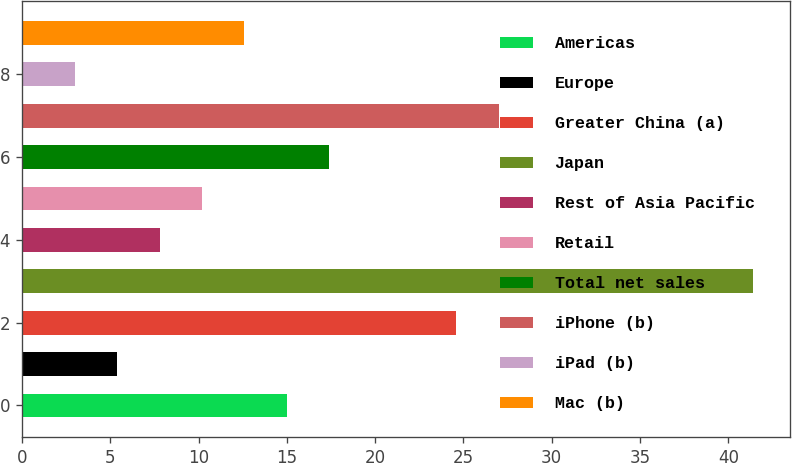Convert chart to OTSL. <chart><loc_0><loc_0><loc_500><loc_500><bar_chart><fcel>Americas<fcel>Europe<fcel>Greater China (a)<fcel>Japan<fcel>Rest of Asia Pacific<fcel>Retail<fcel>Total net sales<fcel>iPhone (b)<fcel>iPad (b)<fcel>Mac (b)<nl><fcel>15<fcel>5.4<fcel>24.6<fcel>41.4<fcel>7.8<fcel>10.2<fcel>17.4<fcel>27<fcel>3<fcel>12.6<nl></chart> 